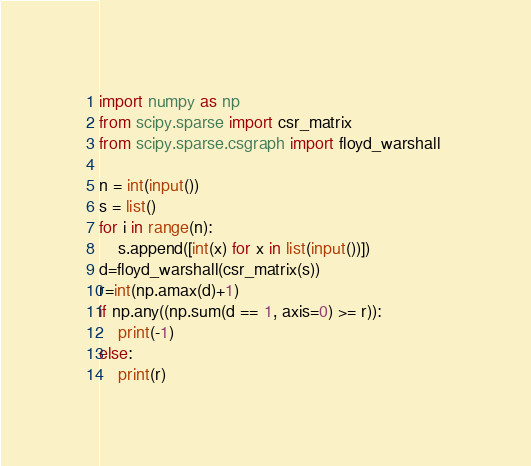<code> <loc_0><loc_0><loc_500><loc_500><_Python_>import numpy as np
from scipy.sparse import csr_matrix
from scipy.sparse.csgraph import floyd_warshall 

n = int(input())
s = list()
for i in range(n):
    s.append([int(x) for x in list(input())])
d=floyd_warshall(csr_matrix(s))
r=int(np.amax(d)+1)
if np.any((np.sum(d == 1, axis=0) >= r)):
    print(-1)
else:
    print(r)</code> 